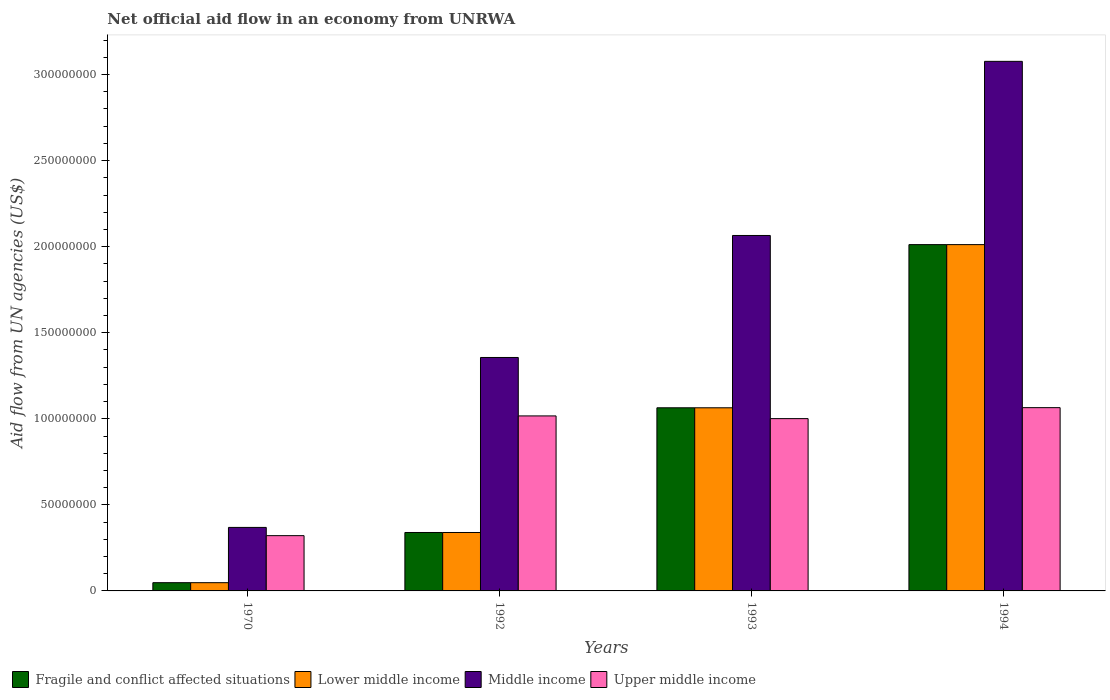How many groups of bars are there?
Your answer should be very brief. 4. How many bars are there on the 2nd tick from the right?
Your response must be concise. 4. In how many cases, is the number of bars for a given year not equal to the number of legend labels?
Make the answer very short. 0. What is the net official aid flow in Fragile and conflict affected situations in 1994?
Offer a very short reply. 2.01e+08. Across all years, what is the maximum net official aid flow in Lower middle income?
Offer a terse response. 2.01e+08. Across all years, what is the minimum net official aid flow in Fragile and conflict affected situations?
Give a very brief answer. 4.79e+06. What is the total net official aid flow in Fragile and conflict affected situations in the graph?
Your response must be concise. 3.46e+08. What is the difference between the net official aid flow in Upper middle income in 1970 and that in 1992?
Keep it short and to the point. -6.96e+07. What is the difference between the net official aid flow in Fragile and conflict affected situations in 1993 and the net official aid flow in Middle income in 1994?
Your answer should be compact. -2.01e+08. What is the average net official aid flow in Middle income per year?
Ensure brevity in your answer.  1.72e+08. In the year 1992, what is the difference between the net official aid flow in Middle income and net official aid flow in Fragile and conflict affected situations?
Give a very brief answer. 1.02e+08. In how many years, is the net official aid flow in Lower middle income greater than 50000000 US$?
Your answer should be compact. 2. What is the ratio of the net official aid flow in Fragile and conflict affected situations in 1970 to that in 1993?
Your answer should be very brief. 0.05. Is the net official aid flow in Fragile and conflict affected situations in 1970 less than that in 1992?
Ensure brevity in your answer.  Yes. Is the difference between the net official aid flow in Middle income in 1993 and 1994 greater than the difference between the net official aid flow in Fragile and conflict affected situations in 1993 and 1994?
Offer a terse response. No. What is the difference between the highest and the second highest net official aid flow in Lower middle income?
Offer a very short reply. 9.48e+07. What is the difference between the highest and the lowest net official aid flow in Upper middle income?
Offer a terse response. 7.44e+07. Is the sum of the net official aid flow in Middle income in 1970 and 1994 greater than the maximum net official aid flow in Upper middle income across all years?
Provide a short and direct response. Yes. Is it the case that in every year, the sum of the net official aid flow in Upper middle income and net official aid flow in Fragile and conflict affected situations is greater than the sum of net official aid flow in Middle income and net official aid flow in Lower middle income?
Offer a very short reply. No. What does the 2nd bar from the left in 1993 represents?
Provide a short and direct response. Lower middle income. What does the 1st bar from the right in 1992 represents?
Offer a very short reply. Upper middle income. Is it the case that in every year, the sum of the net official aid flow in Fragile and conflict affected situations and net official aid flow in Lower middle income is greater than the net official aid flow in Middle income?
Ensure brevity in your answer.  No. How many years are there in the graph?
Offer a very short reply. 4. Does the graph contain any zero values?
Your answer should be very brief. No. Does the graph contain grids?
Your response must be concise. No. How many legend labels are there?
Provide a succinct answer. 4. What is the title of the graph?
Keep it short and to the point. Net official aid flow in an economy from UNRWA. What is the label or title of the Y-axis?
Your response must be concise. Aid flow from UN agencies (US$). What is the Aid flow from UN agencies (US$) in Fragile and conflict affected situations in 1970?
Offer a very short reply. 4.79e+06. What is the Aid flow from UN agencies (US$) in Lower middle income in 1970?
Your answer should be compact. 4.79e+06. What is the Aid flow from UN agencies (US$) of Middle income in 1970?
Ensure brevity in your answer.  3.69e+07. What is the Aid flow from UN agencies (US$) in Upper middle income in 1970?
Make the answer very short. 3.21e+07. What is the Aid flow from UN agencies (US$) in Fragile and conflict affected situations in 1992?
Give a very brief answer. 3.40e+07. What is the Aid flow from UN agencies (US$) of Lower middle income in 1992?
Your answer should be very brief. 3.40e+07. What is the Aid flow from UN agencies (US$) of Middle income in 1992?
Your answer should be very brief. 1.36e+08. What is the Aid flow from UN agencies (US$) of Upper middle income in 1992?
Your answer should be very brief. 1.02e+08. What is the Aid flow from UN agencies (US$) in Fragile and conflict affected situations in 1993?
Provide a succinct answer. 1.06e+08. What is the Aid flow from UN agencies (US$) in Lower middle income in 1993?
Provide a succinct answer. 1.06e+08. What is the Aid flow from UN agencies (US$) in Middle income in 1993?
Offer a terse response. 2.07e+08. What is the Aid flow from UN agencies (US$) in Upper middle income in 1993?
Offer a terse response. 1.00e+08. What is the Aid flow from UN agencies (US$) of Fragile and conflict affected situations in 1994?
Provide a short and direct response. 2.01e+08. What is the Aid flow from UN agencies (US$) of Lower middle income in 1994?
Provide a short and direct response. 2.01e+08. What is the Aid flow from UN agencies (US$) in Middle income in 1994?
Ensure brevity in your answer.  3.08e+08. What is the Aid flow from UN agencies (US$) in Upper middle income in 1994?
Offer a very short reply. 1.06e+08. Across all years, what is the maximum Aid flow from UN agencies (US$) in Fragile and conflict affected situations?
Your response must be concise. 2.01e+08. Across all years, what is the maximum Aid flow from UN agencies (US$) of Lower middle income?
Give a very brief answer. 2.01e+08. Across all years, what is the maximum Aid flow from UN agencies (US$) in Middle income?
Keep it short and to the point. 3.08e+08. Across all years, what is the maximum Aid flow from UN agencies (US$) in Upper middle income?
Your response must be concise. 1.06e+08. Across all years, what is the minimum Aid flow from UN agencies (US$) in Fragile and conflict affected situations?
Provide a short and direct response. 4.79e+06. Across all years, what is the minimum Aid flow from UN agencies (US$) of Lower middle income?
Offer a very short reply. 4.79e+06. Across all years, what is the minimum Aid flow from UN agencies (US$) in Middle income?
Your response must be concise. 3.69e+07. Across all years, what is the minimum Aid flow from UN agencies (US$) in Upper middle income?
Your response must be concise. 3.21e+07. What is the total Aid flow from UN agencies (US$) of Fragile and conflict affected situations in the graph?
Keep it short and to the point. 3.46e+08. What is the total Aid flow from UN agencies (US$) of Lower middle income in the graph?
Your answer should be compact. 3.46e+08. What is the total Aid flow from UN agencies (US$) of Middle income in the graph?
Your answer should be very brief. 6.87e+08. What is the total Aid flow from UN agencies (US$) of Upper middle income in the graph?
Ensure brevity in your answer.  3.40e+08. What is the difference between the Aid flow from UN agencies (US$) in Fragile and conflict affected situations in 1970 and that in 1992?
Your answer should be compact. -2.92e+07. What is the difference between the Aid flow from UN agencies (US$) in Lower middle income in 1970 and that in 1992?
Keep it short and to the point. -2.92e+07. What is the difference between the Aid flow from UN agencies (US$) of Middle income in 1970 and that in 1992?
Your answer should be compact. -9.87e+07. What is the difference between the Aid flow from UN agencies (US$) of Upper middle income in 1970 and that in 1992?
Provide a succinct answer. -6.96e+07. What is the difference between the Aid flow from UN agencies (US$) in Fragile and conflict affected situations in 1970 and that in 1993?
Offer a very short reply. -1.02e+08. What is the difference between the Aid flow from UN agencies (US$) of Lower middle income in 1970 and that in 1993?
Provide a succinct answer. -1.02e+08. What is the difference between the Aid flow from UN agencies (US$) of Middle income in 1970 and that in 1993?
Your answer should be compact. -1.70e+08. What is the difference between the Aid flow from UN agencies (US$) of Upper middle income in 1970 and that in 1993?
Your response must be concise. -6.80e+07. What is the difference between the Aid flow from UN agencies (US$) of Fragile and conflict affected situations in 1970 and that in 1994?
Your answer should be very brief. -1.96e+08. What is the difference between the Aid flow from UN agencies (US$) in Lower middle income in 1970 and that in 1994?
Give a very brief answer. -1.96e+08. What is the difference between the Aid flow from UN agencies (US$) of Middle income in 1970 and that in 1994?
Your response must be concise. -2.71e+08. What is the difference between the Aid flow from UN agencies (US$) in Upper middle income in 1970 and that in 1994?
Keep it short and to the point. -7.44e+07. What is the difference between the Aid flow from UN agencies (US$) in Fragile and conflict affected situations in 1992 and that in 1993?
Offer a very short reply. -7.24e+07. What is the difference between the Aid flow from UN agencies (US$) of Lower middle income in 1992 and that in 1993?
Make the answer very short. -7.24e+07. What is the difference between the Aid flow from UN agencies (US$) of Middle income in 1992 and that in 1993?
Keep it short and to the point. -7.09e+07. What is the difference between the Aid flow from UN agencies (US$) of Upper middle income in 1992 and that in 1993?
Offer a terse response. 1.57e+06. What is the difference between the Aid flow from UN agencies (US$) of Fragile and conflict affected situations in 1992 and that in 1994?
Your response must be concise. -1.67e+08. What is the difference between the Aid flow from UN agencies (US$) in Lower middle income in 1992 and that in 1994?
Give a very brief answer. -1.67e+08. What is the difference between the Aid flow from UN agencies (US$) in Middle income in 1992 and that in 1994?
Your answer should be compact. -1.72e+08. What is the difference between the Aid flow from UN agencies (US$) in Upper middle income in 1992 and that in 1994?
Provide a succinct answer. -4.80e+06. What is the difference between the Aid flow from UN agencies (US$) in Fragile and conflict affected situations in 1993 and that in 1994?
Provide a succinct answer. -9.48e+07. What is the difference between the Aid flow from UN agencies (US$) in Lower middle income in 1993 and that in 1994?
Make the answer very short. -9.48e+07. What is the difference between the Aid flow from UN agencies (US$) in Middle income in 1993 and that in 1994?
Provide a succinct answer. -1.01e+08. What is the difference between the Aid flow from UN agencies (US$) of Upper middle income in 1993 and that in 1994?
Provide a succinct answer. -6.37e+06. What is the difference between the Aid flow from UN agencies (US$) of Fragile and conflict affected situations in 1970 and the Aid flow from UN agencies (US$) of Lower middle income in 1992?
Your answer should be compact. -2.92e+07. What is the difference between the Aid flow from UN agencies (US$) in Fragile and conflict affected situations in 1970 and the Aid flow from UN agencies (US$) in Middle income in 1992?
Offer a terse response. -1.31e+08. What is the difference between the Aid flow from UN agencies (US$) in Fragile and conflict affected situations in 1970 and the Aid flow from UN agencies (US$) in Upper middle income in 1992?
Give a very brief answer. -9.69e+07. What is the difference between the Aid flow from UN agencies (US$) in Lower middle income in 1970 and the Aid flow from UN agencies (US$) in Middle income in 1992?
Your answer should be very brief. -1.31e+08. What is the difference between the Aid flow from UN agencies (US$) of Lower middle income in 1970 and the Aid flow from UN agencies (US$) of Upper middle income in 1992?
Offer a terse response. -9.69e+07. What is the difference between the Aid flow from UN agencies (US$) of Middle income in 1970 and the Aid flow from UN agencies (US$) of Upper middle income in 1992?
Provide a succinct answer. -6.48e+07. What is the difference between the Aid flow from UN agencies (US$) of Fragile and conflict affected situations in 1970 and the Aid flow from UN agencies (US$) of Lower middle income in 1993?
Keep it short and to the point. -1.02e+08. What is the difference between the Aid flow from UN agencies (US$) in Fragile and conflict affected situations in 1970 and the Aid flow from UN agencies (US$) in Middle income in 1993?
Your answer should be very brief. -2.02e+08. What is the difference between the Aid flow from UN agencies (US$) of Fragile and conflict affected situations in 1970 and the Aid flow from UN agencies (US$) of Upper middle income in 1993?
Ensure brevity in your answer.  -9.53e+07. What is the difference between the Aid flow from UN agencies (US$) in Lower middle income in 1970 and the Aid flow from UN agencies (US$) in Middle income in 1993?
Make the answer very short. -2.02e+08. What is the difference between the Aid flow from UN agencies (US$) in Lower middle income in 1970 and the Aid flow from UN agencies (US$) in Upper middle income in 1993?
Provide a succinct answer. -9.53e+07. What is the difference between the Aid flow from UN agencies (US$) of Middle income in 1970 and the Aid flow from UN agencies (US$) of Upper middle income in 1993?
Provide a succinct answer. -6.32e+07. What is the difference between the Aid flow from UN agencies (US$) of Fragile and conflict affected situations in 1970 and the Aid flow from UN agencies (US$) of Lower middle income in 1994?
Offer a terse response. -1.96e+08. What is the difference between the Aid flow from UN agencies (US$) in Fragile and conflict affected situations in 1970 and the Aid flow from UN agencies (US$) in Middle income in 1994?
Offer a very short reply. -3.03e+08. What is the difference between the Aid flow from UN agencies (US$) of Fragile and conflict affected situations in 1970 and the Aid flow from UN agencies (US$) of Upper middle income in 1994?
Offer a very short reply. -1.02e+08. What is the difference between the Aid flow from UN agencies (US$) in Lower middle income in 1970 and the Aid flow from UN agencies (US$) in Middle income in 1994?
Offer a very short reply. -3.03e+08. What is the difference between the Aid flow from UN agencies (US$) of Lower middle income in 1970 and the Aid flow from UN agencies (US$) of Upper middle income in 1994?
Ensure brevity in your answer.  -1.02e+08. What is the difference between the Aid flow from UN agencies (US$) of Middle income in 1970 and the Aid flow from UN agencies (US$) of Upper middle income in 1994?
Offer a terse response. -6.96e+07. What is the difference between the Aid flow from UN agencies (US$) in Fragile and conflict affected situations in 1992 and the Aid flow from UN agencies (US$) in Lower middle income in 1993?
Give a very brief answer. -7.24e+07. What is the difference between the Aid flow from UN agencies (US$) of Fragile and conflict affected situations in 1992 and the Aid flow from UN agencies (US$) of Middle income in 1993?
Your answer should be compact. -1.73e+08. What is the difference between the Aid flow from UN agencies (US$) of Fragile and conflict affected situations in 1992 and the Aid flow from UN agencies (US$) of Upper middle income in 1993?
Your answer should be compact. -6.62e+07. What is the difference between the Aid flow from UN agencies (US$) in Lower middle income in 1992 and the Aid flow from UN agencies (US$) in Middle income in 1993?
Offer a very short reply. -1.73e+08. What is the difference between the Aid flow from UN agencies (US$) of Lower middle income in 1992 and the Aid flow from UN agencies (US$) of Upper middle income in 1993?
Your answer should be compact. -6.62e+07. What is the difference between the Aid flow from UN agencies (US$) in Middle income in 1992 and the Aid flow from UN agencies (US$) in Upper middle income in 1993?
Your response must be concise. 3.55e+07. What is the difference between the Aid flow from UN agencies (US$) of Fragile and conflict affected situations in 1992 and the Aid flow from UN agencies (US$) of Lower middle income in 1994?
Make the answer very short. -1.67e+08. What is the difference between the Aid flow from UN agencies (US$) of Fragile and conflict affected situations in 1992 and the Aid flow from UN agencies (US$) of Middle income in 1994?
Your answer should be compact. -2.74e+08. What is the difference between the Aid flow from UN agencies (US$) of Fragile and conflict affected situations in 1992 and the Aid flow from UN agencies (US$) of Upper middle income in 1994?
Provide a succinct answer. -7.25e+07. What is the difference between the Aid flow from UN agencies (US$) of Lower middle income in 1992 and the Aid flow from UN agencies (US$) of Middle income in 1994?
Your answer should be compact. -2.74e+08. What is the difference between the Aid flow from UN agencies (US$) of Lower middle income in 1992 and the Aid flow from UN agencies (US$) of Upper middle income in 1994?
Offer a terse response. -7.25e+07. What is the difference between the Aid flow from UN agencies (US$) of Middle income in 1992 and the Aid flow from UN agencies (US$) of Upper middle income in 1994?
Give a very brief answer. 2.92e+07. What is the difference between the Aid flow from UN agencies (US$) of Fragile and conflict affected situations in 1993 and the Aid flow from UN agencies (US$) of Lower middle income in 1994?
Provide a succinct answer. -9.48e+07. What is the difference between the Aid flow from UN agencies (US$) of Fragile and conflict affected situations in 1993 and the Aid flow from UN agencies (US$) of Middle income in 1994?
Ensure brevity in your answer.  -2.01e+08. What is the difference between the Aid flow from UN agencies (US$) of Lower middle income in 1993 and the Aid flow from UN agencies (US$) of Middle income in 1994?
Your answer should be compact. -2.01e+08. What is the difference between the Aid flow from UN agencies (US$) of Middle income in 1993 and the Aid flow from UN agencies (US$) of Upper middle income in 1994?
Make the answer very short. 1.00e+08. What is the average Aid flow from UN agencies (US$) in Fragile and conflict affected situations per year?
Offer a terse response. 8.66e+07. What is the average Aid flow from UN agencies (US$) of Lower middle income per year?
Your answer should be very brief. 8.66e+07. What is the average Aid flow from UN agencies (US$) in Middle income per year?
Provide a short and direct response. 1.72e+08. What is the average Aid flow from UN agencies (US$) of Upper middle income per year?
Your answer should be compact. 8.51e+07. In the year 1970, what is the difference between the Aid flow from UN agencies (US$) in Fragile and conflict affected situations and Aid flow from UN agencies (US$) in Middle income?
Your response must be concise. -3.21e+07. In the year 1970, what is the difference between the Aid flow from UN agencies (US$) in Fragile and conflict affected situations and Aid flow from UN agencies (US$) in Upper middle income?
Give a very brief answer. -2.73e+07. In the year 1970, what is the difference between the Aid flow from UN agencies (US$) of Lower middle income and Aid flow from UN agencies (US$) of Middle income?
Provide a succinct answer. -3.21e+07. In the year 1970, what is the difference between the Aid flow from UN agencies (US$) of Lower middle income and Aid flow from UN agencies (US$) of Upper middle income?
Keep it short and to the point. -2.73e+07. In the year 1970, what is the difference between the Aid flow from UN agencies (US$) in Middle income and Aid flow from UN agencies (US$) in Upper middle income?
Ensure brevity in your answer.  4.79e+06. In the year 1992, what is the difference between the Aid flow from UN agencies (US$) of Fragile and conflict affected situations and Aid flow from UN agencies (US$) of Lower middle income?
Offer a very short reply. 0. In the year 1992, what is the difference between the Aid flow from UN agencies (US$) of Fragile and conflict affected situations and Aid flow from UN agencies (US$) of Middle income?
Ensure brevity in your answer.  -1.02e+08. In the year 1992, what is the difference between the Aid flow from UN agencies (US$) of Fragile and conflict affected situations and Aid flow from UN agencies (US$) of Upper middle income?
Your answer should be compact. -6.77e+07. In the year 1992, what is the difference between the Aid flow from UN agencies (US$) of Lower middle income and Aid flow from UN agencies (US$) of Middle income?
Your answer should be compact. -1.02e+08. In the year 1992, what is the difference between the Aid flow from UN agencies (US$) in Lower middle income and Aid flow from UN agencies (US$) in Upper middle income?
Provide a succinct answer. -6.77e+07. In the year 1992, what is the difference between the Aid flow from UN agencies (US$) of Middle income and Aid flow from UN agencies (US$) of Upper middle income?
Offer a very short reply. 3.40e+07. In the year 1993, what is the difference between the Aid flow from UN agencies (US$) of Fragile and conflict affected situations and Aid flow from UN agencies (US$) of Lower middle income?
Offer a terse response. 0. In the year 1993, what is the difference between the Aid flow from UN agencies (US$) in Fragile and conflict affected situations and Aid flow from UN agencies (US$) in Middle income?
Make the answer very short. -1.00e+08. In the year 1993, what is the difference between the Aid flow from UN agencies (US$) in Fragile and conflict affected situations and Aid flow from UN agencies (US$) in Upper middle income?
Your response must be concise. 6.29e+06. In the year 1993, what is the difference between the Aid flow from UN agencies (US$) in Lower middle income and Aid flow from UN agencies (US$) in Middle income?
Make the answer very short. -1.00e+08. In the year 1993, what is the difference between the Aid flow from UN agencies (US$) of Lower middle income and Aid flow from UN agencies (US$) of Upper middle income?
Your answer should be very brief. 6.29e+06. In the year 1993, what is the difference between the Aid flow from UN agencies (US$) of Middle income and Aid flow from UN agencies (US$) of Upper middle income?
Ensure brevity in your answer.  1.06e+08. In the year 1994, what is the difference between the Aid flow from UN agencies (US$) in Fragile and conflict affected situations and Aid flow from UN agencies (US$) in Middle income?
Give a very brief answer. -1.06e+08. In the year 1994, what is the difference between the Aid flow from UN agencies (US$) of Fragile and conflict affected situations and Aid flow from UN agencies (US$) of Upper middle income?
Give a very brief answer. 9.47e+07. In the year 1994, what is the difference between the Aid flow from UN agencies (US$) in Lower middle income and Aid flow from UN agencies (US$) in Middle income?
Offer a very short reply. -1.06e+08. In the year 1994, what is the difference between the Aid flow from UN agencies (US$) in Lower middle income and Aid flow from UN agencies (US$) in Upper middle income?
Your answer should be very brief. 9.47e+07. In the year 1994, what is the difference between the Aid flow from UN agencies (US$) of Middle income and Aid flow from UN agencies (US$) of Upper middle income?
Offer a very short reply. 2.01e+08. What is the ratio of the Aid flow from UN agencies (US$) of Fragile and conflict affected situations in 1970 to that in 1992?
Ensure brevity in your answer.  0.14. What is the ratio of the Aid flow from UN agencies (US$) in Lower middle income in 1970 to that in 1992?
Keep it short and to the point. 0.14. What is the ratio of the Aid flow from UN agencies (US$) of Middle income in 1970 to that in 1992?
Your response must be concise. 0.27. What is the ratio of the Aid flow from UN agencies (US$) in Upper middle income in 1970 to that in 1992?
Provide a short and direct response. 0.32. What is the ratio of the Aid flow from UN agencies (US$) in Fragile and conflict affected situations in 1970 to that in 1993?
Provide a succinct answer. 0.04. What is the ratio of the Aid flow from UN agencies (US$) of Lower middle income in 1970 to that in 1993?
Provide a succinct answer. 0.04. What is the ratio of the Aid flow from UN agencies (US$) of Middle income in 1970 to that in 1993?
Offer a very short reply. 0.18. What is the ratio of the Aid flow from UN agencies (US$) of Upper middle income in 1970 to that in 1993?
Offer a terse response. 0.32. What is the ratio of the Aid flow from UN agencies (US$) in Fragile and conflict affected situations in 1970 to that in 1994?
Offer a terse response. 0.02. What is the ratio of the Aid flow from UN agencies (US$) of Lower middle income in 1970 to that in 1994?
Offer a terse response. 0.02. What is the ratio of the Aid flow from UN agencies (US$) of Middle income in 1970 to that in 1994?
Your response must be concise. 0.12. What is the ratio of the Aid flow from UN agencies (US$) in Upper middle income in 1970 to that in 1994?
Make the answer very short. 0.3. What is the ratio of the Aid flow from UN agencies (US$) in Fragile and conflict affected situations in 1992 to that in 1993?
Provide a short and direct response. 0.32. What is the ratio of the Aid flow from UN agencies (US$) in Lower middle income in 1992 to that in 1993?
Keep it short and to the point. 0.32. What is the ratio of the Aid flow from UN agencies (US$) in Middle income in 1992 to that in 1993?
Ensure brevity in your answer.  0.66. What is the ratio of the Aid flow from UN agencies (US$) of Upper middle income in 1992 to that in 1993?
Keep it short and to the point. 1.02. What is the ratio of the Aid flow from UN agencies (US$) in Fragile and conflict affected situations in 1992 to that in 1994?
Your answer should be very brief. 0.17. What is the ratio of the Aid flow from UN agencies (US$) in Lower middle income in 1992 to that in 1994?
Ensure brevity in your answer.  0.17. What is the ratio of the Aid flow from UN agencies (US$) in Middle income in 1992 to that in 1994?
Offer a terse response. 0.44. What is the ratio of the Aid flow from UN agencies (US$) in Upper middle income in 1992 to that in 1994?
Give a very brief answer. 0.95. What is the ratio of the Aid flow from UN agencies (US$) of Fragile and conflict affected situations in 1993 to that in 1994?
Your response must be concise. 0.53. What is the ratio of the Aid flow from UN agencies (US$) of Lower middle income in 1993 to that in 1994?
Ensure brevity in your answer.  0.53. What is the ratio of the Aid flow from UN agencies (US$) of Middle income in 1993 to that in 1994?
Give a very brief answer. 0.67. What is the ratio of the Aid flow from UN agencies (US$) of Upper middle income in 1993 to that in 1994?
Offer a terse response. 0.94. What is the difference between the highest and the second highest Aid flow from UN agencies (US$) of Fragile and conflict affected situations?
Give a very brief answer. 9.48e+07. What is the difference between the highest and the second highest Aid flow from UN agencies (US$) of Lower middle income?
Provide a short and direct response. 9.48e+07. What is the difference between the highest and the second highest Aid flow from UN agencies (US$) in Middle income?
Provide a short and direct response. 1.01e+08. What is the difference between the highest and the second highest Aid flow from UN agencies (US$) of Upper middle income?
Keep it short and to the point. 4.80e+06. What is the difference between the highest and the lowest Aid flow from UN agencies (US$) in Fragile and conflict affected situations?
Provide a succinct answer. 1.96e+08. What is the difference between the highest and the lowest Aid flow from UN agencies (US$) of Lower middle income?
Your answer should be compact. 1.96e+08. What is the difference between the highest and the lowest Aid flow from UN agencies (US$) in Middle income?
Provide a succinct answer. 2.71e+08. What is the difference between the highest and the lowest Aid flow from UN agencies (US$) of Upper middle income?
Make the answer very short. 7.44e+07. 